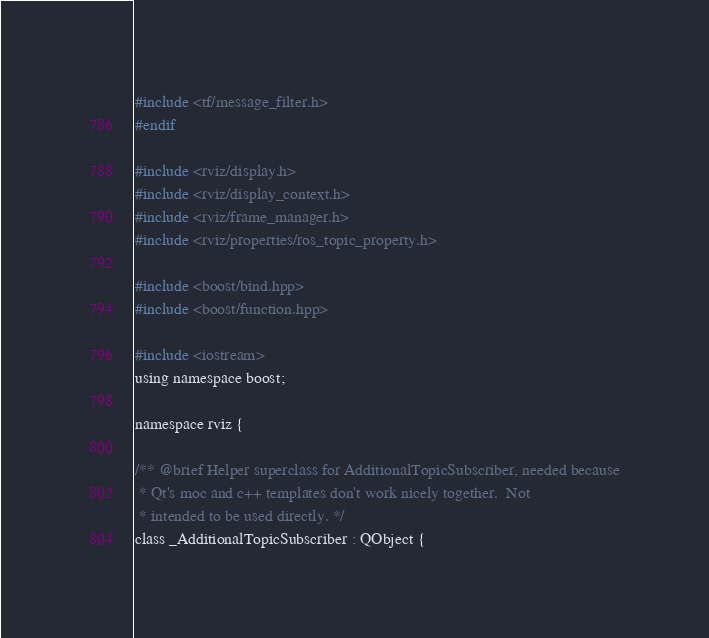Convert code to text. <code><loc_0><loc_0><loc_500><loc_500><_C_>#include <tf/message_filter.h>
#endif

#include <rviz/display.h>
#include <rviz/display_context.h>
#include <rviz/frame_manager.h>
#include <rviz/properties/ros_topic_property.h>

#include <boost/bind.hpp>
#include <boost/function.hpp>

#include <iostream>
using namespace boost;

namespace rviz {

/** @brief Helper superclass for AdditionalTopicSubscriber, needed because
 * Qt's moc and c++ templates don't work nicely together.  Not
 * intended to be used directly. */
class _AdditionalTopicSubscriber : QObject {</code> 